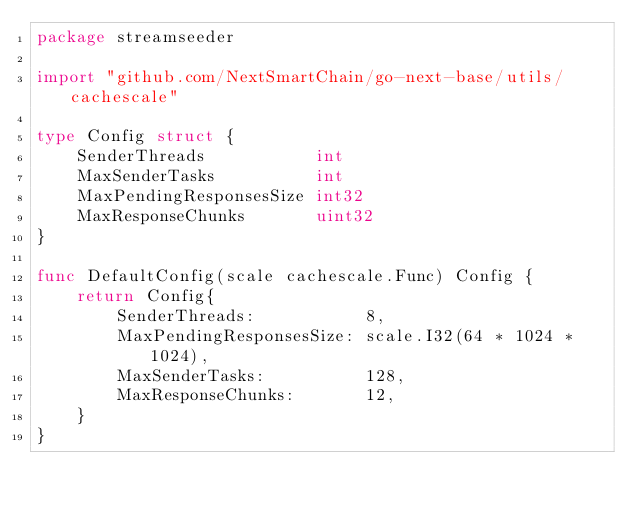Convert code to text. <code><loc_0><loc_0><loc_500><loc_500><_Go_>package streamseeder

import "github.com/NextSmartChain/go-next-base/utils/cachescale"

type Config struct {
	SenderThreads           int
	MaxSenderTasks          int
	MaxPendingResponsesSize int32
	MaxResponseChunks       uint32
}

func DefaultConfig(scale cachescale.Func) Config {
	return Config{
		SenderThreads:           8,
		MaxPendingResponsesSize: scale.I32(64 * 1024 * 1024),
		MaxSenderTasks:          128,
		MaxResponseChunks:       12,
	}
}
</code> 